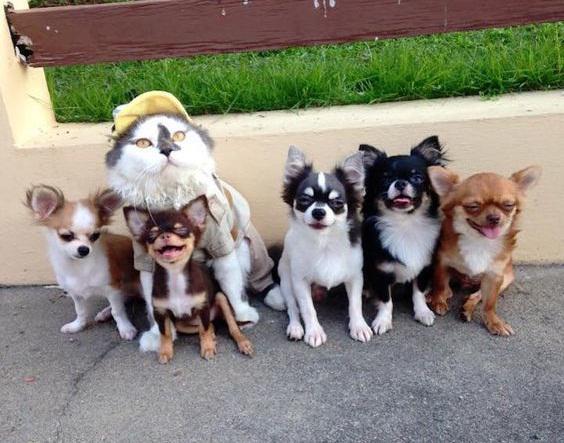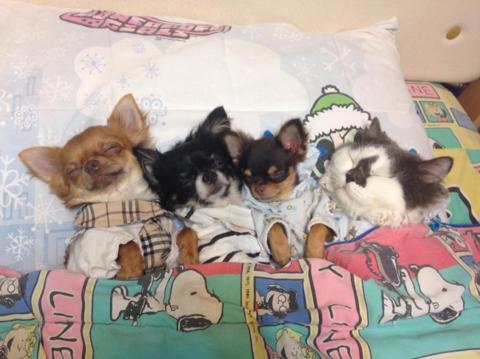The first image is the image on the left, the second image is the image on the right. Examine the images to the left and right. Is the description "Multiple small dogs and one cat pose on a pet bed outdoors on pavement in one image." accurate? Answer yes or no. No. 